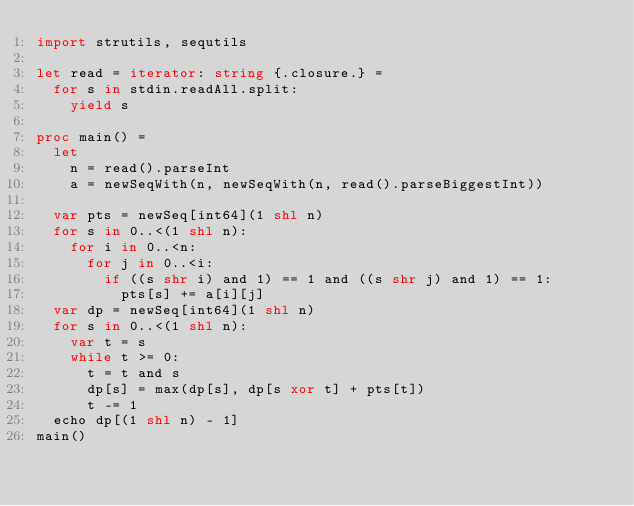Convert code to text. <code><loc_0><loc_0><loc_500><loc_500><_Nim_>import strutils, sequtils

let read = iterator: string {.closure.} =
  for s in stdin.readAll.split:
    yield s

proc main() =
  let
    n = read().parseInt
    a = newSeqWith(n, newSeqWith(n, read().parseBiggestInt))

  var pts = newSeq[int64](1 shl n)
  for s in 0..<(1 shl n):
    for i in 0..<n:
      for j in 0..<i:
        if ((s shr i) and 1) == 1 and ((s shr j) and 1) == 1:
          pts[s] += a[i][j]
  var dp = newSeq[int64](1 shl n)
  for s in 0..<(1 shl n):
    var t = s
    while t >= 0:
      t = t and s
      dp[s] = max(dp[s], dp[s xor t] + pts[t])
      t -= 1
  echo dp[(1 shl n) - 1]
main()
</code> 